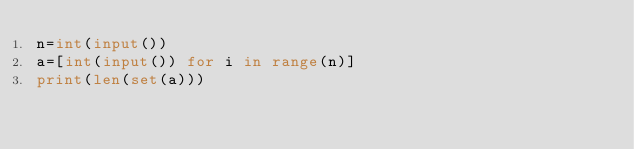Convert code to text. <code><loc_0><loc_0><loc_500><loc_500><_Python_>n=int(input())
a=[int(input()) for i in range(n)]
print(len(set(a)))</code> 